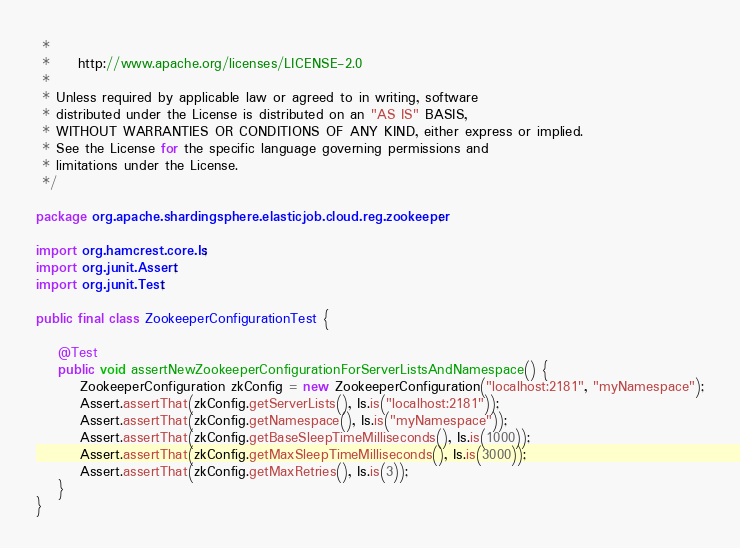<code> <loc_0><loc_0><loc_500><loc_500><_Java_> *
 *     http://www.apache.org/licenses/LICENSE-2.0
 *
 * Unless required by applicable law or agreed to in writing, software
 * distributed under the License is distributed on an "AS IS" BASIS,
 * WITHOUT WARRANTIES OR CONDITIONS OF ANY KIND, either express or implied.
 * See the License for the specific language governing permissions and
 * limitations under the License.
 */

package org.apache.shardingsphere.elasticjob.cloud.reg.zookeeper;

import org.hamcrest.core.Is;
import org.junit.Assert;
import org.junit.Test;

public final class ZookeeperConfigurationTest {
    
    @Test
    public void assertNewZookeeperConfigurationForServerListsAndNamespace() {
        ZookeeperConfiguration zkConfig = new ZookeeperConfiguration("localhost:2181", "myNamespace");
        Assert.assertThat(zkConfig.getServerLists(), Is.is("localhost:2181"));
        Assert.assertThat(zkConfig.getNamespace(), Is.is("myNamespace"));
        Assert.assertThat(zkConfig.getBaseSleepTimeMilliseconds(), Is.is(1000));
        Assert.assertThat(zkConfig.getMaxSleepTimeMilliseconds(), Is.is(3000));
        Assert.assertThat(zkConfig.getMaxRetries(), Is.is(3));
    }
}
</code> 